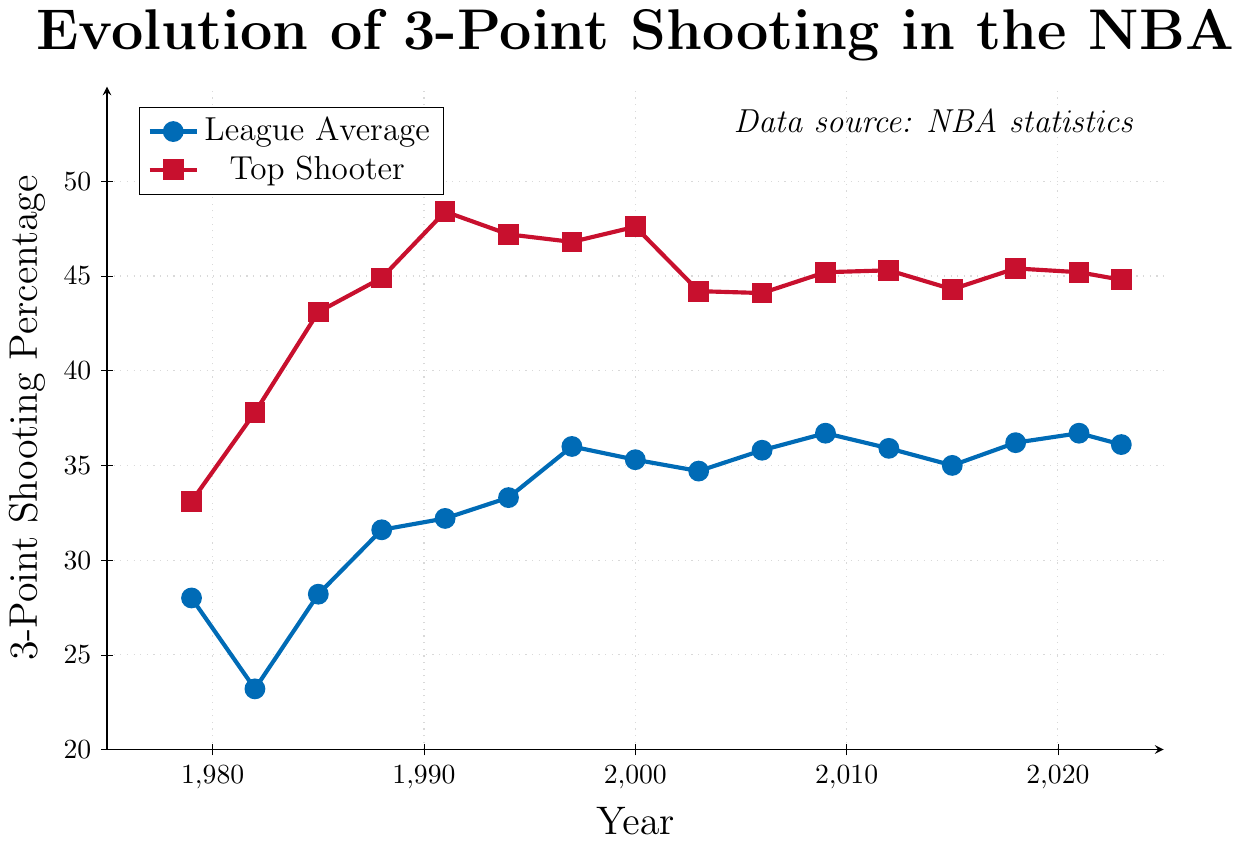What is the highest 3-point shooting percentage achieved by the top shooter? The top shooter reached the highest 3-point shooting percentage in 1991, with a value of 48.4%.
Answer: 48.4% What is the overall trend in the league average 3-point shooting percentage from 1979 to 2023? From 1979 to 2023, the league average 3-point shooting percentage shows an increasing trend, starting at 28.0% in 1979 and reaching 36.1% in 2023, with some fluctuations in between.
Answer: Increasing trend In which year was the gap between the league average and the top shooter the smallest? The gap between the league average and the top shooter was smallest in 1979, where the gap was 5.1 percentage points (top shooter: 33.1% - league average: 28.0%).
Answer: 1979 What is the difference in the 3-point shooting percentage between the league average and the top shooter in 2000? In 2000, the league average was 35.3% and the top shooter was 47.6%. The difference is 47.6% - 35.3% = 12.3%.
Answer: 12.3% Between what years did the league average 3-point shooting percentage surpass 35%? The league average 3-point shooting percentage surpassed 35% for the first time in 1997 and remained above that mark through 2023, with some minor fluctuations below 35%.
Answer: 1997 and 2023 Compare the league average 3-point shooting percentage in 1985 and 2015. Which year has a higher percentage? In 1985, the league average was 28.2%, while in 2015, it was 35.0%. Thus, 2015 has a higher 3-point shooting percentage.
Answer: 2015 In which year did the top shooter’s 3-point percentage first exceed 45%? The top shooter's 3-point percentage first exceeded 45% in 1988, with a percentage of 44.9%.
Answer: 1988 How many years did the league average 3-point shooting percentage decrease compared to the previous year? By observing the plot, the league average 3-point shooting percentage decreased in 1982, 2003, 2012, 2015, and 2023, which sums up to 5 years.
Answer: 5 years What is the average 3-point shooting percentage of top shooters over the years presented in the figure? Summing the top shooter's percentages: 33.1 + 37.8 + 43.1 + 44.9 + 48.4 + 47.2 + 46.8 + 47.6 + 44.2 + 44.1 + 45.2 + 45.3 + 44.3 + 45.4 + 45.2 + 44.8 = 707.4. Dividing by the 16 years, the average is 707.4 / 16 ≈ 44.2%.
Answer: 44.2% Which year shows the largest gap between the league average and the top shooter, and what is the gap? In 1991, the league average 3-point shooting percentage was 32.2% and the top shooter's percentage was 48.4%. The gap is 48.4% - 32.2% = 16.2%, which is the largest gap shown in the figure.
Answer: 1991, 16.2% 